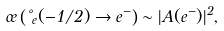<formula> <loc_0><loc_0><loc_500><loc_500>\sigma \left ( \nu _ { e } ( - 1 / 2 ) \to e ^ { - } \right ) \sim | A ( e ^ { - } ) | ^ { 2 } ,</formula> 